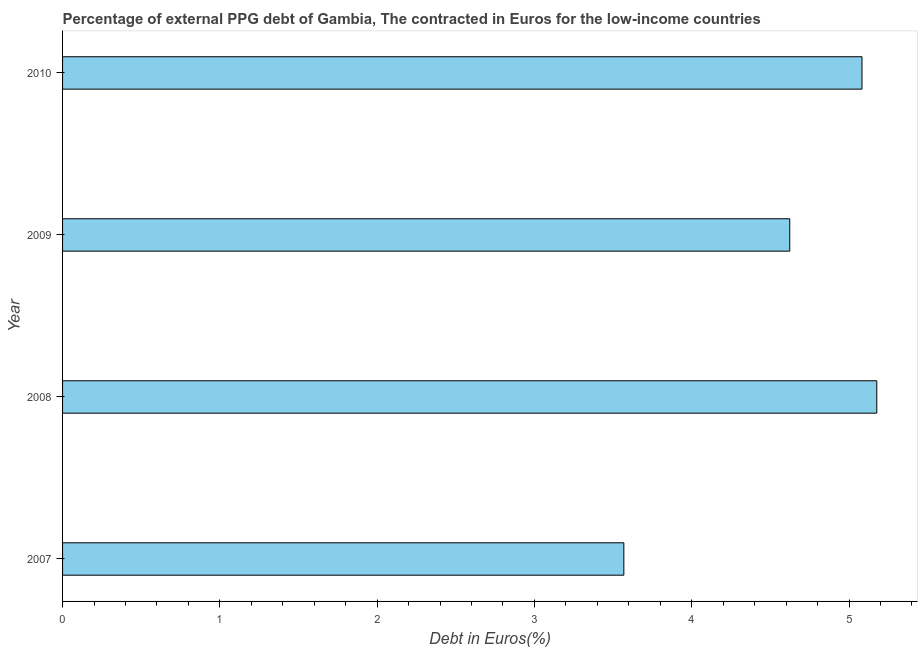Does the graph contain any zero values?
Your response must be concise. No. Does the graph contain grids?
Keep it short and to the point. No. What is the title of the graph?
Offer a very short reply. Percentage of external PPG debt of Gambia, The contracted in Euros for the low-income countries. What is the label or title of the X-axis?
Your answer should be very brief. Debt in Euros(%). What is the label or title of the Y-axis?
Ensure brevity in your answer.  Year. What is the currency composition of ppg debt in 2008?
Your answer should be very brief. 5.18. Across all years, what is the maximum currency composition of ppg debt?
Offer a terse response. 5.18. Across all years, what is the minimum currency composition of ppg debt?
Provide a short and direct response. 3.57. In which year was the currency composition of ppg debt maximum?
Your answer should be very brief. 2008. In which year was the currency composition of ppg debt minimum?
Ensure brevity in your answer.  2007. What is the sum of the currency composition of ppg debt?
Give a very brief answer. 18.45. What is the difference between the currency composition of ppg debt in 2007 and 2010?
Your response must be concise. -1.51. What is the average currency composition of ppg debt per year?
Offer a very short reply. 4.61. What is the median currency composition of ppg debt?
Make the answer very short. 4.85. In how many years, is the currency composition of ppg debt greater than 4.2 %?
Keep it short and to the point. 3. Do a majority of the years between 2010 and 2007 (inclusive) have currency composition of ppg debt greater than 1.2 %?
Make the answer very short. Yes. What is the ratio of the currency composition of ppg debt in 2007 to that in 2009?
Your answer should be very brief. 0.77. Is the currency composition of ppg debt in 2009 less than that in 2010?
Provide a succinct answer. Yes. What is the difference between the highest and the second highest currency composition of ppg debt?
Keep it short and to the point. 0.09. What is the difference between the highest and the lowest currency composition of ppg debt?
Offer a terse response. 1.61. How many bars are there?
Give a very brief answer. 4. What is the difference between two consecutive major ticks on the X-axis?
Offer a terse response. 1. What is the Debt in Euros(%) in 2007?
Keep it short and to the point. 3.57. What is the Debt in Euros(%) of 2008?
Provide a short and direct response. 5.18. What is the Debt in Euros(%) in 2009?
Give a very brief answer. 4.62. What is the Debt in Euros(%) in 2010?
Ensure brevity in your answer.  5.08. What is the difference between the Debt in Euros(%) in 2007 and 2008?
Give a very brief answer. -1.61. What is the difference between the Debt in Euros(%) in 2007 and 2009?
Give a very brief answer. -1.05. What is the difference between the Debt in Euros(%) in 2007 and 2010?
Provide a succinct answer. -1.51. What is the difference between the Debt in Euros(%) in 2008 and 2009?
Your answer should be very brief. 0.55. What is the difference between the Debt in Euros(%) in 2008 and 2010?
Your response must be concise. 0.09. What is the difference between the Debt in Euros(%) in 2009 and 2010?
Your answer should be compact. -0.46. What is the ratio of the Debt in Euros(%) in 2007 to that in 2008?
Give a very brief answer. 0.69. What is the ratio of the Debt in Euros(%) in 2007 to that in 2009?
Ensure brevity in your answer.  0.77. What is the ratio of the Debt in Euros(%) in 2007 to that in 2010?
Your answer should be compact. 0.7. What is the ratio of the Debt in Euros(%) in 2008 to that in 2009?
Provide a succinct answer. 1.12. What is the ratio of the Debt in Euros(%) in 2008 to that in 2010?
Your answer should be compact. 1.02. What is the ratio of the Debt in Euros(%) in 2009 to that in 2010?
Ensure brevity in your answer.  0.91. 